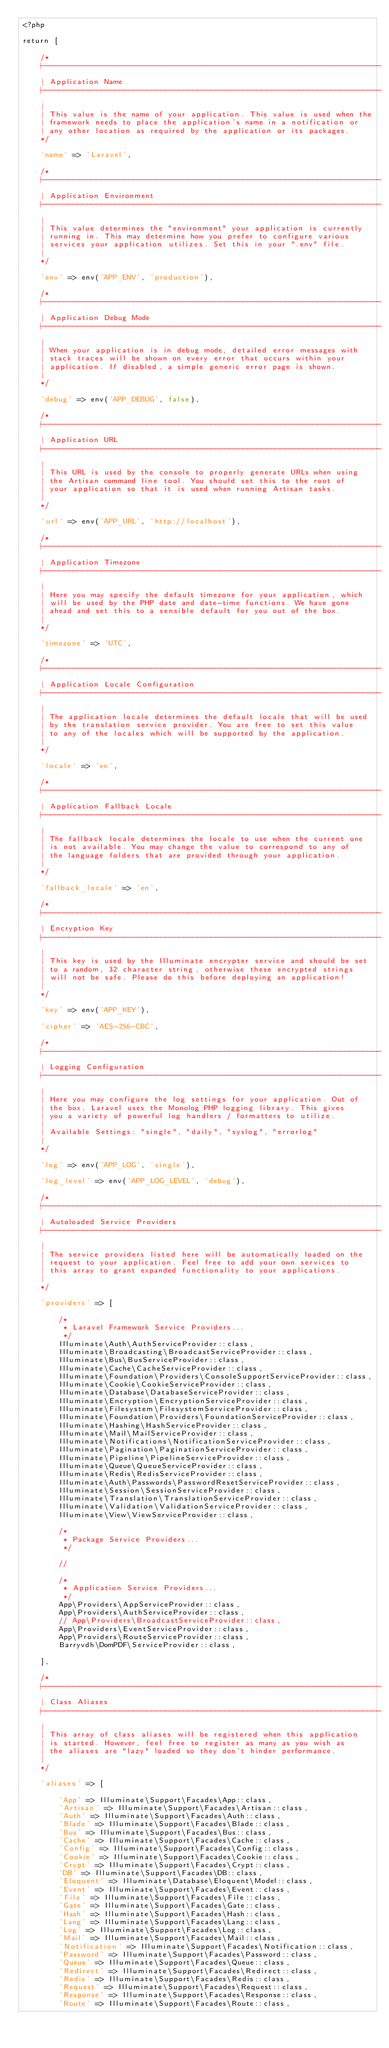Convert code to text. <code><loc_0><loc_0><loc_500><loc_500><_PHP_><?php

return [

    /*
    |--------------------------------------------------------------------------
    | Application Name
    |--------------------------------------------------------------------------
    |
    | This value is the name of your application. This value is used when the
    | framework needs to place the application's name in a notification or
    | any other location as required by the application or its packages.
    */

    'name' => 'Laravel',

    /*
    |--------------------------------------------------------------------------
    | Application Environment
    |--------------------------------------------------------------------------
    |
    | This value determines the "environment" your application is currently
    | running in. This may determine how you prefer to configure various
    | services your application utilizes. Set this in your ".env" file.
    |
    */

    'env' => env('APP_ENV', 'production'),

    /*
    |--------------------------------------------------------------------------
    | Application Debug Mode
    |--------------------------------------------------------------------------
    |
    | When your application is in debug mode, detailed error messages with
    | stack traces will be shown on every error that occurs within your
    | application. If disabled, a simple generic error page is shown.
    |
    */

    'debug' => env('APP_DEBUG', false),

    /*
    |--------------------------------------------------------------------------
    | Application URL
    |--------------------------------------------------------------------------
    |
    | This URL is used by the console to properly generate URLs when using
    | the Artisan command line tool. You should set this to the root of
    | your application so that it is used when running Artisan tasks.
    |
    */

    'url' => env('APP_URL', 'http://localhost'),

    /*
    |--------------------------------------------------------------------------
    | Application Timezone
    |--------------------------------------------------------------------------
    |
    | Here you may specify the default timezone for your application, which
    | will be used by the PHP date and date-time functions. We have gone
    | ahead and set this to a sensible default for you out of the box.
    |
    */

    'timezone' => 'UTC',

    /*
    |--------------------------------------------------------------------------
    | Application Locale Configuration
    |--------------------------------------------------------------------------
    |
    | The application locale determines the default locale that will be used
    | by the translation service provider. You are free to set this value
    | to any of the locales which will be supported by the application.
    |
    */

    'locale' => 'en',

    /*
    |--------------------------------------------------------------------------
    | Application Fallback Locale
    |--------------------------------------------------------------------------
    |
    | The fallback locale determines the locale to use when the current one
    | is not available. You may change the value to correspond to any of
    | the language folders that are provided through your application.
    |
    */

    'fallback_locale' => 'en',

    /*
    |--------------------------------------------------------------------------
    | Encryption Key
    |--------------------------------------------------------------------------
    |
    | This key is used by the Illuminate encrypter service and should be set
    | to a random, 32 character string, otherwise these encrypted strings
    | will not be safe. Please do this before deploying an application!
    |
    */

    'key' => env('APP_KEY'),

    'cipher' => 'AES-256-CBC',

    /*
    |--------------------------------------------------------------------------
    | Logging Configuration
    |--------------------------------------------------------------------------
    |
    | Here you may configure the log settings for your application. Out of
    | the box, Laravel uses the Monolog PHP logging library. This gives
    | you a variety of powerful log handlers / formatters to utilize.
    |
    | Available Settings: "single", "daily", "syslog", "errorlog"
    |
    */

    'log' => env('APP_LOG', 'single'),

    'log_level' => env('APP_LOG_LEVEL', 'debug'),

    /*
    |--------------------------------------------------------------------------
    | Autoloaded Service Providers
    |--------------------------------------------------------------------------
    |
    | The service providers listed here will be automatically loaded on the
    | request to your application. Feel free to add your own services to
    | this array to grant expanded functionality to your applications.
    |
    */

    'providers' => [

        /*
         * Laravel Framework Service Providers...
         */
        Illuminate\Auth\AuthServiceProvider::class,
        Illuminate\Broadcasting\BroadcastServiceProvider::class,
        Illuminate\Bus\BusServiceProvider::class,
        Illuminate\Cache\CacheServiceProvider::class,
        Illuminate\Foundation\Providers\ConsoleSupportServiceProvider::class,
        Illuminate\Cookie\CookieServiceProvider::class,
        Illuminate\Database\DatabaseServiceProvider::class,
        Illuminate\Encryption\EncryptionServiceProvider::class,
        Illuminate\Filesystem\FilesystemServiceProvider::class,
        Illuminate\Foundation\Providers\FoundationServiceProvider::class,
        Illuminate\Hashing\HashServiceProvider::class,
        Illuminate\Mail\MailServiceProvider::class,
        Illuminate\Notifications\NotificationServiceProvider::class,
        Illuminate\Pagination\PaginationServiceProvider::class,
        Illuminate\Pipeline\PipelineServiceProvider::class,
        Illuminate\Queue\QueueServiceProvider::class,
        Illuminate\Redis\RedisServiceProvider::class,
        Illuminate\Auth\Passwords\PasswordResetServiceProvider::class,
        Illuminate\Session\SessionServiceProvider::class,
        Illuminate\Translation\TranslationServiceProvider::class,
        Illuminate\Validation\ValidationServiceProvider::class,
        Illuminate\View\ViewServiceProvider::class,

        /*
         * Package Service Providers...
         */

        //

        /*
         * Application Service Providers...
         */
        App\Providers\AppServiceProvider::class,
        App\Providers\AuthServiceProvider::class,
        // App\Providers\BroadcastServiceProvider::class,
        App\Providers\EventServiceProvider::class,
        App\Providers\RouteServiceProvider::class,
        Barryvdh\DomPDF\ServiceProvider::class,

    ],

    /*
    |--------------------------------------------------------------------------
    | Class Aliases
    |--------------------------------------------------------------------------
    |
    | This array of class aliases will be registered when this application
    | is started. However, feel free to register as many as you wish as
    | the aliases are "lazy" loaded so they don't hinder performance.
    |
    */

    'aliases' => [

        'App' => Illuminate\Support\Facades\App::class,
        'Artisan' => Illuminate\Support\Facades\Artisan::class,
        'Auth' => Illuminate\Support\Facades\Auth::class,
        'Blade' => Illuminate\Support\Facades\Blade::class,
        'Bus' => Illuminate\Support\Facades\Bus::class,
        'Cache' => Illuminate\Support\Facades\Cache::class,
        'Config' => Illuminate\Support\Facades\Config::class,
        'Cookie' => Illuminate\Support\Facades\Cookie::class,
        'Crypt' => Illuminate\Support\Facades\Crypt::class,
        'DB' => Illuminate\Support\Facades\DB::class,
        'Eloquent' => Illuminate\Database\Eloquent\Model::class,
        'Event' => Illuminate\Support\Facades\Event::class,
        'File' => Illuminate\Support\Facades\File::class,
        'Gate' => Illuminate\Support\Facades\Gate::class,
        'Hash' => Illuminate\Support\Facades\Hash::class,
        'Lang' => Illuminate\Support\Facades\Lang::class,
        'Log' => Illuminate\Support\Facades\Log::class,
        'Mail' => Illuminate\Support\Facades\Mail::class,
        'Notification' => Illuminate\Support\Facades\Notification::class,
        'Password' => Illuminate\Support\Facades\Password::class,
        'Queue' => Illuminate\Support\Facades\Queue::class,
        'Redirect' => Illuminate\Support\Facades\Redirect::class,
        'Redis' => Illuminate\Support\Facades\Redis::class,
        'Request' => Illuminate\Support\Facades\Request::class,
        'Response' => Illuminate\Support\Facades\Response::class,
        'Route' => Illuminate\Support\Facades\Route::class,</code> 